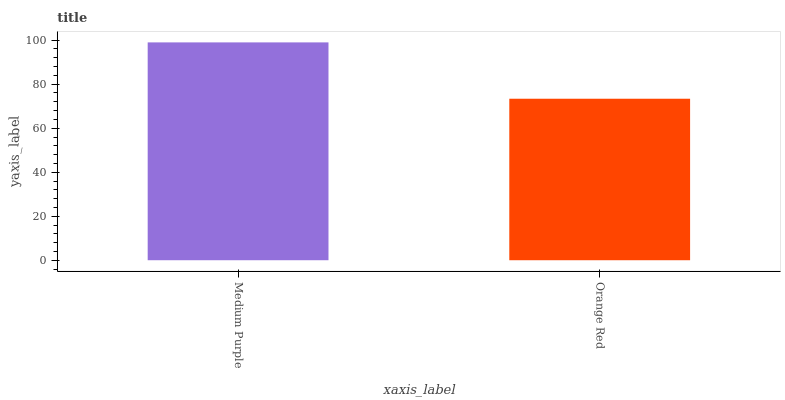Is Orange Red the minimum?
Answer yes or no. Yes. Is Medium Purple the maximum?
Answer yes or no. Yes. Is Orange Red the maximum?
Answer yes or no. No. Is Medium Purple greater than Orange Red?
Answer yes or no. Yes. Is Orange Red less than Medium Purple?
Answer yes or no. Yes. Is Orange Red greater than Medium Purple?
Answer yes or no. No. Is Medium Purple less than Orange Red?
Answer yes or no. No. Is Medium Purple the high median?
Answer yes or no. Yes. Is Orange Red the low median?
Answer yes or no. Yes. Is Orange Red the high median?
Answer yes or no. No. Is Medium Purple the low median?
Answer yes or no. No. 